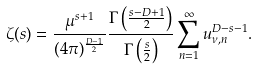Convert formula to latex. <formula><loc_0><loc_0><loc_500><loc_500>\zeta ( s ) = \frac { \mu ^ { s + 1 } } { ( 4 \pi ) ^ { \frac { D - 1 } { 2 } } } \frac { \Gamma \left ( \frac { s - D + 1 } { 2 } \right ) } { \Gamma \left ( \frac { s } { 2 } \right ) } \sum _ { n = 1 } ^ { \infty } u _ { \nu , n } ^ { D - s - 1 } .</formula> 